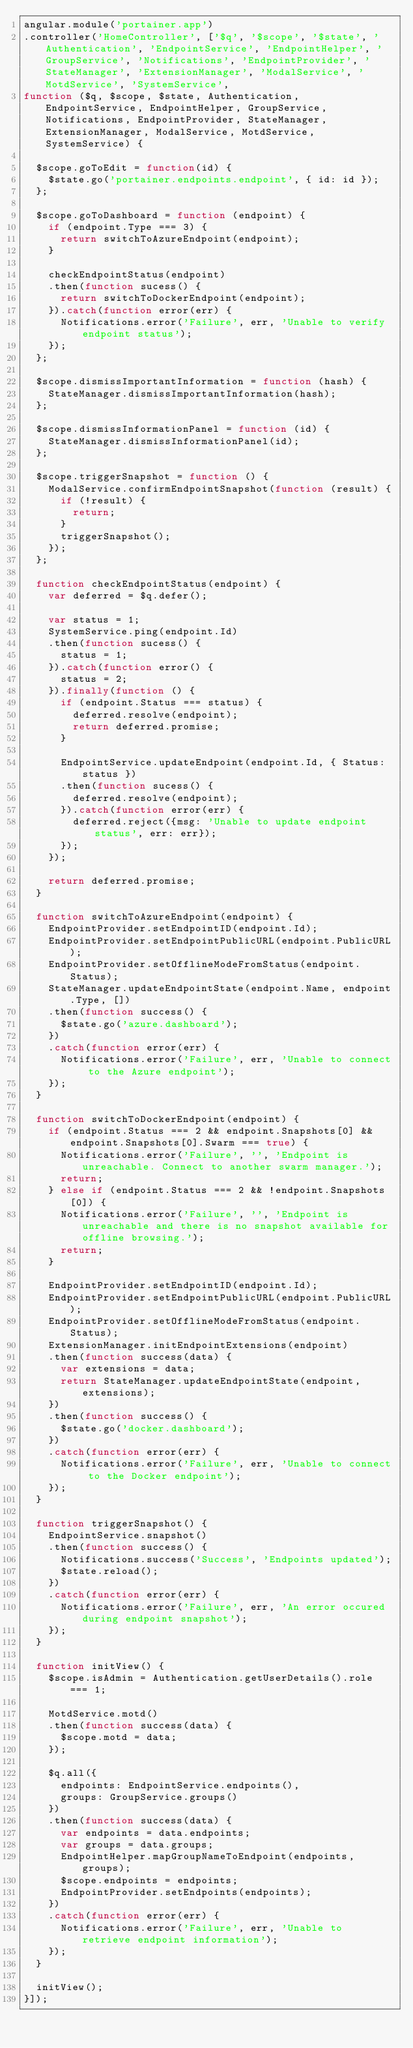Convert code to text. <code><loc_0><loc_0><loc_500><loc_500><_JavaScript_>angular.module('portainer.app')
.controller('HomeController', ['$q', '$scope', '$state', 'Authentication', 'EndpointService', 'EndpointHelper', 'GroupService', 'Notifications', 'EndpointProvider', 'StateManager', 'ExtensionManager', 'ModalService', 'MotdService', 'SystemService',
function ($q, $scope, $state, Authentication, EndpointService, EndpointHelper, GroupService, Notifications, EndpointProvider, StateManager, ExtensionManager, ModalService, MotdService, SystemService) {

  $scope.goToEdit = function(id) {
    $state.go('portainer.endpoints.endpoint', { id: id });
  };

  $scope.goToDashboard = function (endpoint) {
    if (endpoint.Type === 3) {
      return switchToAzureEndpoint(endpoint);
    }

    checkEndpointStatus(endpoint)
    .then(function sucess() {
      return switchToDockerEndpoint(endpoint);
    }).catch(function error(err) {
      Notifications.error('Failure', err, 'Unable to verify endpoint status');
    });
  };

  $scope.dismissImportantInformation = function (hash) {
    StateManager.dismissImportantInformation(hash);
  };

  $scope.dismissInformationPanel = function (id) {
    StateManager.dismissInformationPanel(id);
  };

  $scope.triggerSnapshot = function () {
    ModalService.confirmEndpointSnapshot(function (result) {
      if (!result) {
        return;
      }
      triggerSnapshot();
    });
  };

  function checkEndpointStatus(endpoint) {
    var deferred = $q.defer();

    var status = 1;
    SystemService.ping(endpoint.Id)
    .then(function sucess() {
      status = 1;
    }).catch(function error() {
      status = 2;
    }).finally(function () {
      if (endpoint.Status === status) {
        deferred.resolve(endpoint);
        return deferred.promise;
      }

      EndpointService.updateEndpoint(endpoint.Id, { Status: status })
      .then(function sucess() {
        deferred.resolve(endpoint);
      }).catch(function error(err) {
        deferred.reject({msg: 'Unable to update endpoint status', err: err});
      });
    });

    return deferred.promise;
  }

  function switchToAzureEndpoint(endpoint) {
    EndpointProvider.setEndpointID(endpoint.Id);
    EndpointProvider.setEndpointPublicURL(endpoint.PublicURL);
    EndpointProvider.setOfflineModeFromStatus(endpoint.Status);
    StateManager.updateEndpointState(endpoint.Name, endpoint.Type, [])
    .then(function success() {
      $state.go('azure.dashboard');
    })
    .catch(function error(err) {
      Notifications.error('Failure', err, 'Unable to connect to the Azure endpoint');
    });
  }

  function switchToDockerEndpoint(endpoint) {
    if (endpoint.Status === 2 && endpoint.Snapshots[0] && endpoint.Snapshots[0].Swarm === true) {
      Notifications.error('Failure', '', 'Endpoint is unreachable. Connect to another swarm manager.');
      return;
    } else if (endpoint.Status === 2 && !endpoint.Snapshots[0]) {
      Notifications.error('Failure', '', 'Endpoint is unreachable and there is no snapshot available for offline browsing.');
      return;
    }

    EndpointProvider.setEndpointID(endpoint.Id);
    EndpointProvider.setEndpointPublicURL(endpoint.PublicURL);
    EndpointProvider.setOfflineModeFromStatus(endpoint.Status);
    ExtensionManager.initEndpointExtensions(endpoint)
    .then(function success(data) {
      var extensions = data;
      return StateManager.updateEndpointState(endpoint, extensions);
    })
    .then(function success() {
      $state.go('docker.dashboard');
    })
    .catch(function error(err) {
      Notifications.error('Failure', err, 'Unable to connect to the Docker endpoint');
    });
  }

  function triggerSnapshot() {
    EndpointService.snapshot()
    .then(function success() {
      Notifications.success('Success', 'Endpoints updated');
      $state.reload();
    })
    .catch(function error(err) {
      Notifications.error('Failure', err, 'An error occured during endpoint snapshot');
    });
  }

  function initView() {
    $scope.isAdmin = Authentication.getUserDetails().role === 1;

    MotdService.motd()
    .then(function success(data) {
      $scope.motd = data;
    });

    $q.all({
      endpoints: EndpointService.endpoints(),
      groups: GroupService.groups()
    })
    .then(function success(data) {
      var endpoints = data.endpoints;
      var groups = data.groups;
      EndpointHelper.mapGroupNameToEndpoint(endpoints, groups);
      $scope.endpoints = endpoints;
      EndpointProvider.setEndpoints(endpoints);
    })
    .catch(function error(err) {
      Notifications.error('Failure', err, 'Unable to retrieve endpoint information');
    });
  }

  initView();
}]);
</code> 